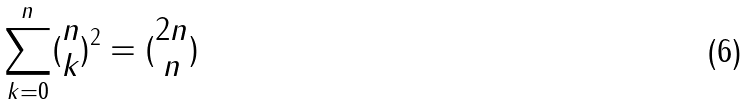<formula> <loc_0><loc_0><loc_500><loc_500>\sum _ { k = 0 } ^ { n } ( \begin{matrix} n \\ k \end{matrix} ) ^ { 2 } = ( \begin{matrix} 2 n \\ n \end{matrix} )</formula> 